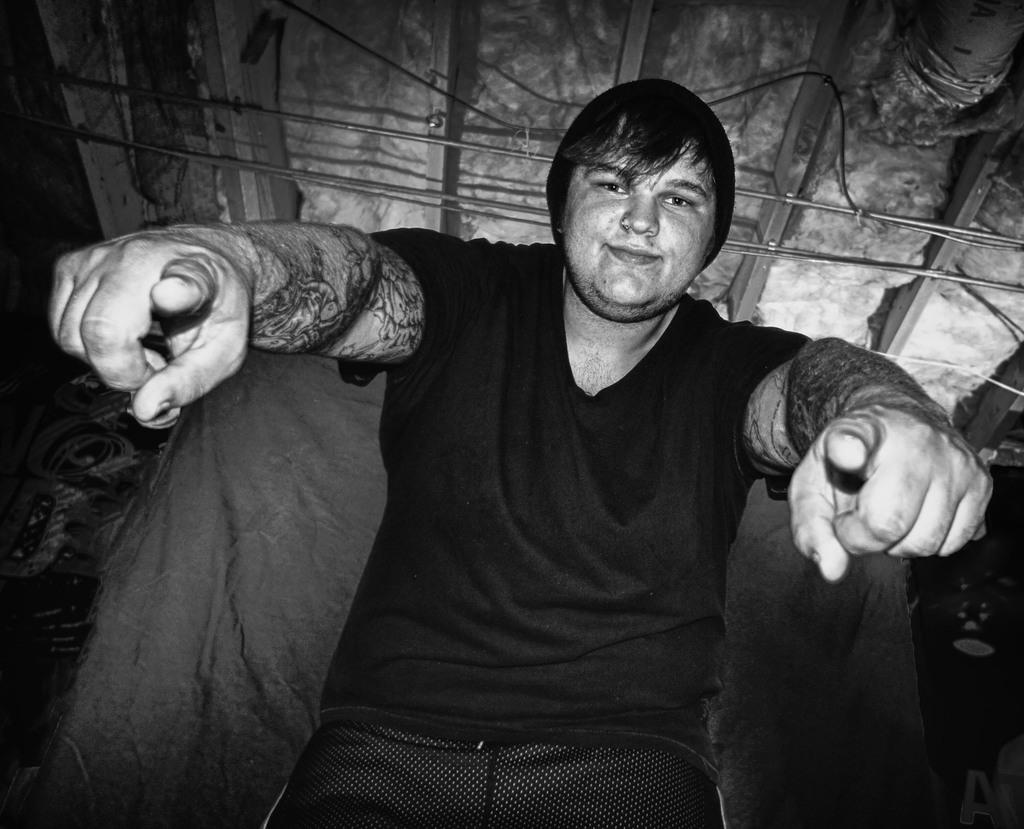Who is present in the image? There is a man in the image. What is the man's facial expression? The man is smiling. What type of material can be seen in the image? There is cloth in the image. What objects are made of a more rigid material? There are rods and wire in the image. What book is the man reading in the image? There is no book present in the image. How much profit is the man making from the cloth in the image? There is no information about profit or any financial transactions in the image. 